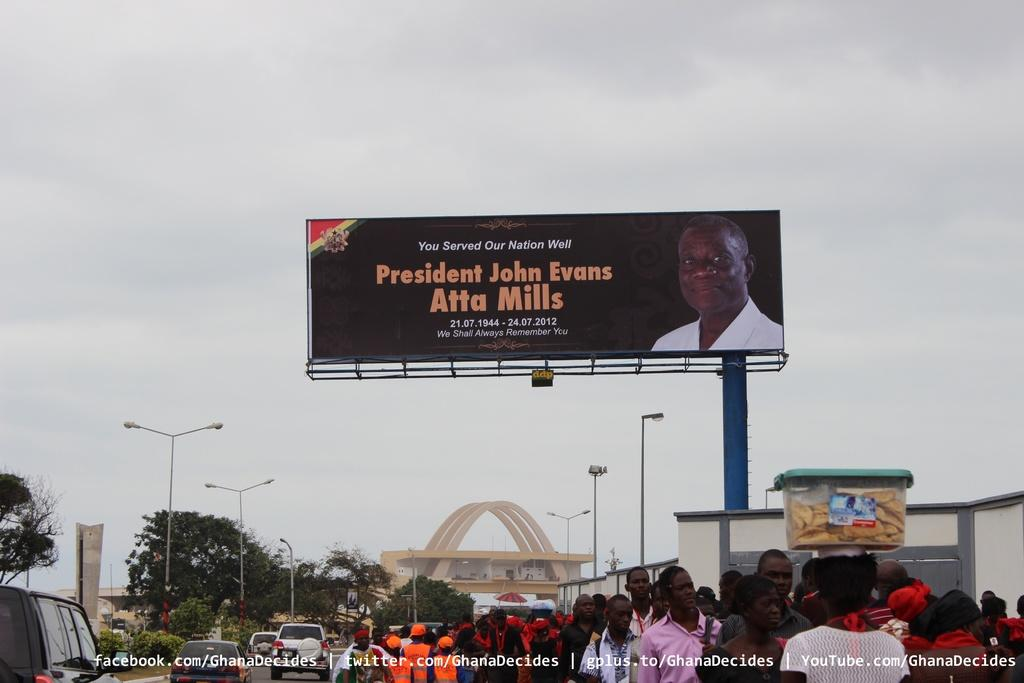<image>
Relay a brief, clear account of the picture shown. A billboard for President John Evans stands tall above a crowd 